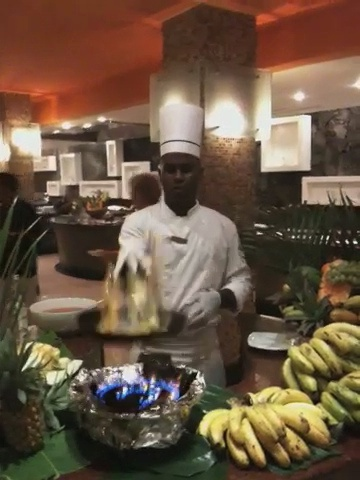Describe the objects in this image and their specific colors. I can see people in maroon, darkgray, black, and gray tones, banana in maroon, khaki, tan, and olive tones, banana in maroon, tan, olive, black, and khaki tones, bowl in maroon, tan, black, and gray tones, and banana in maroon, olive, and black tones in this image. 